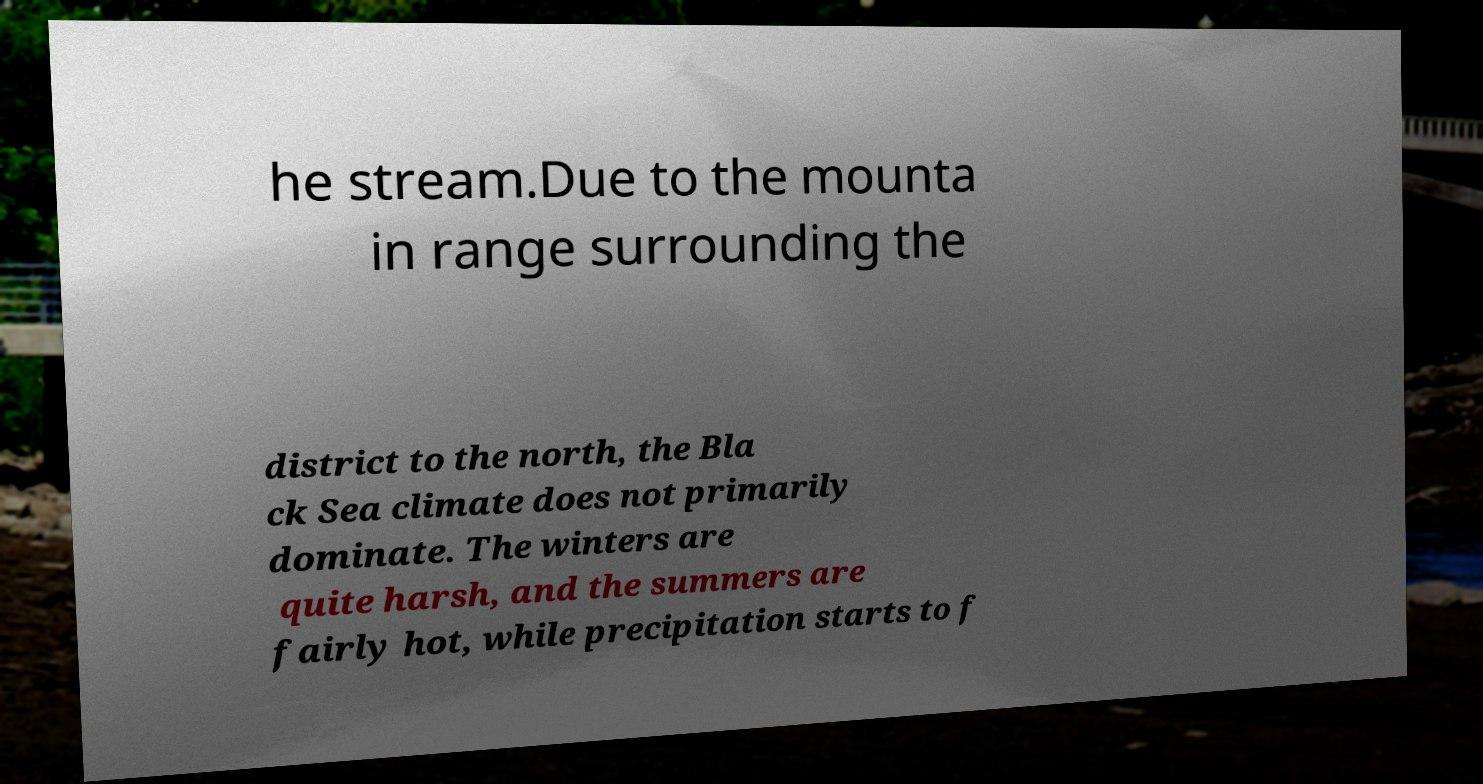Can you read and provide the text displayed in the image?This photo seems to have some interesting text. Can you extract and type it out for me? he stream.Due to the mounta in range surrounding the district to the north, the Bla ck Sea climate does not primarily dominate. The winters are quite harsh, and the summers are fairly hot, while precipitation starts to f 